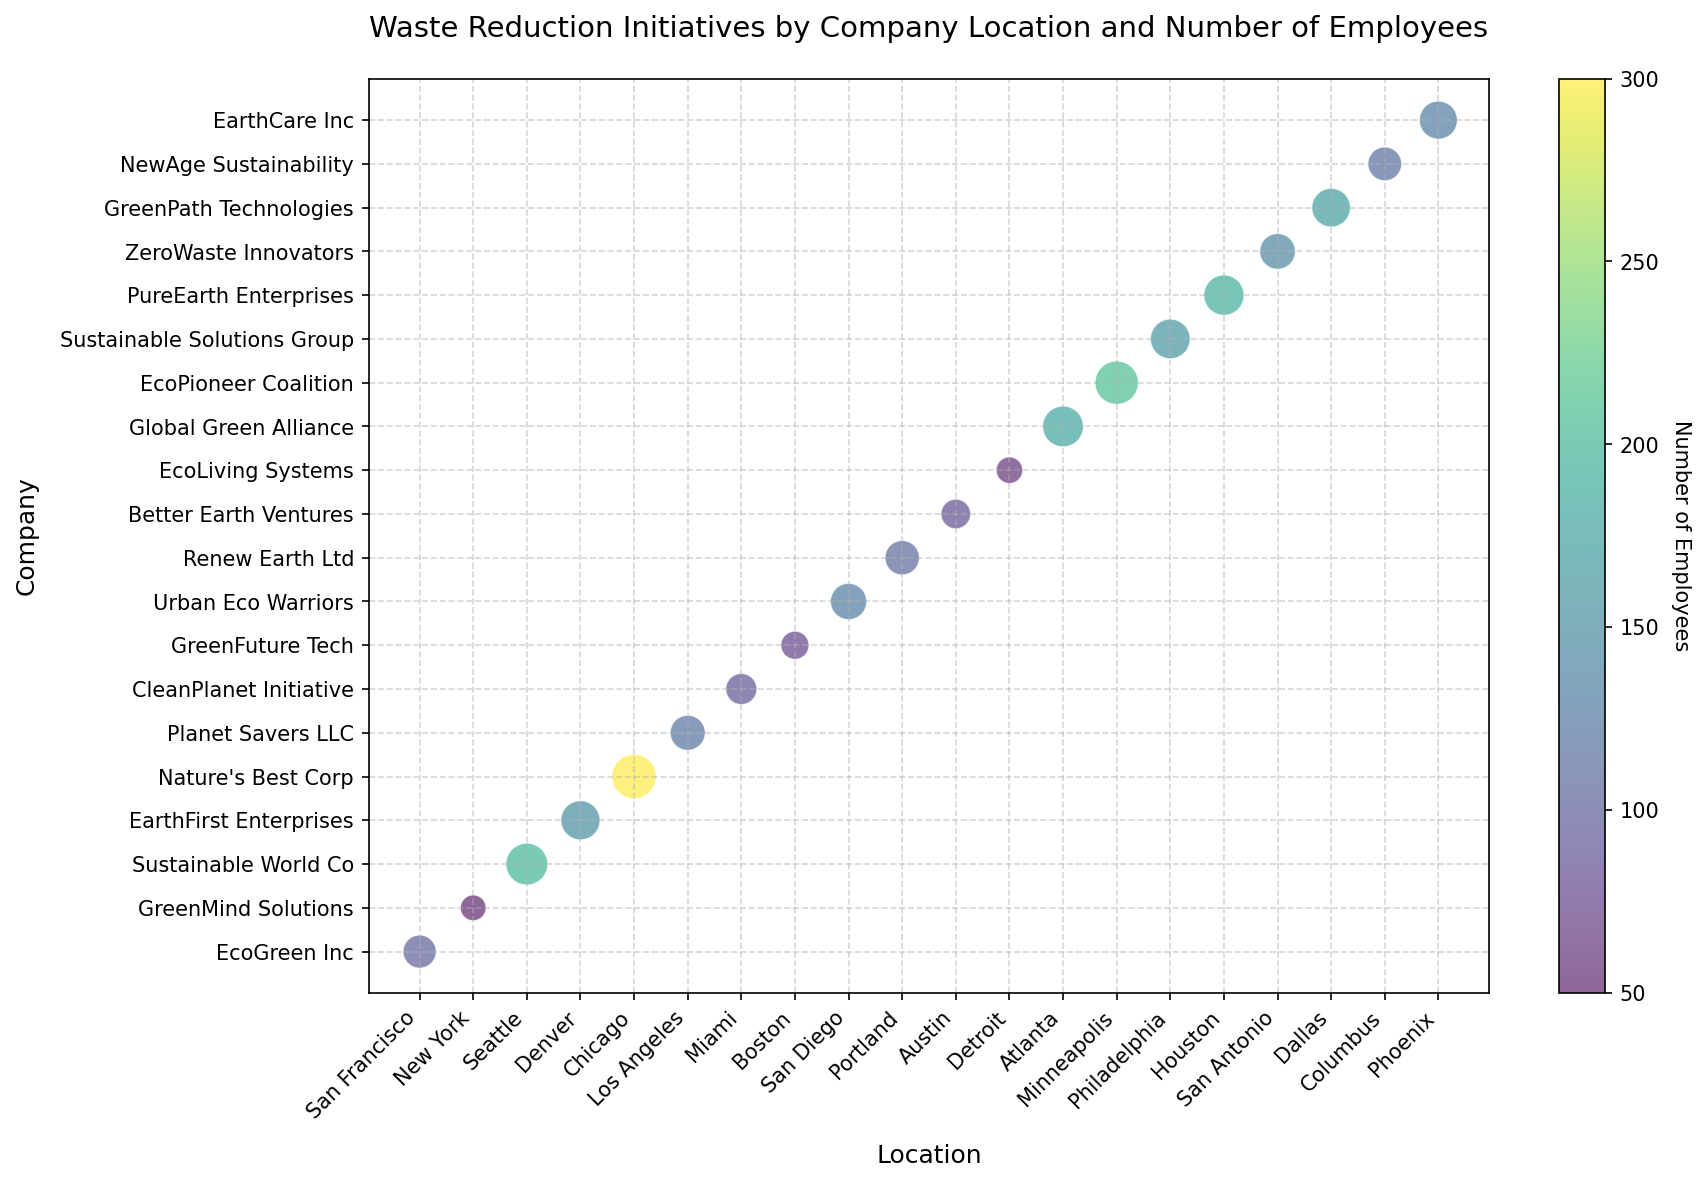Which company has the highest number of employees? The color bar on the right represents the number of employees. By checking the color intensity across all companies, the company located the most towards the high end of the color spectrum (deepest color) is Nature's Best Corp.
Answer: Nature's Best Corp Which company in New York has the lowest waste reduction efforts? Locate the bubble corresponding to New York. There is only one company, GreenMind Solutions, and the waste reduction value is the lowest.
Answer: GreenMind Solutions How many companies have more than 100 employees but less than 150 employees? Count the circles with color representing employee numbers between 100 and 150. Five companies meet the criteria: EarthFirst Enterprises, Urban Eco Warriors, Planet Savers LLC, Renew Earth Ltd, and EarthCare Inc.
Answer: 5 Which company in Los Angeles has the highest waste reduction efforts? Locate the bubble in Los Angeles. There's only one company, Planet Savers LLC, and its waste reduction value is 28.
Answer: Planet Savers LLC What is the total waste reduction of companies located in Texas? Locate the companies in Texas: PureEarth Enterprises (37) in Houston and ZeroWaste Innovators (29) in San Antonio. Sum their values: 37 + 29 = 66.
Answer: 66 Which location has the company with the highest waste reduction value? Look for the largest bubble. Nature's Best Corp in Chicago has the highest value at 45.
Answer: Chicago Are there any companies with equal waste reduction displaying 30 in different locations? EarthCare Inc in Phoenix and Urban Eco Warriors in San Diego both show a 30-unit waste reduction initiative.
Answer: Yes Compare the waste reduction between the company with the highest number of employees and the lowest number of employees. Nature's Best Corp in Chicago has the highest number of employees (300) and a waste reduction of 45. GreenMind Solutions in New York has the lowest number of employees (50) and a waste reduction of 15.
Answer: 45 for highest, 15 for lowest How many companies in California are represented in the chart? Locate bubbles in California: San Francisco (EcoGreen Inc), Los Angeles (Planet Savers LLC), San Diego (Urban Eco Warriors). This gives 3 companies.
Answer: 3 What is the average waste reduction of companies with more than 200 employees? Identify companies with >200 employees: Sustainable World Co (40), EcoPioneer Coalition (43), and Nature's Best Corp (45). Sum waste reductions: 40 + 43 + 45 = 128. Divide by 3.
Answer: 42.67 